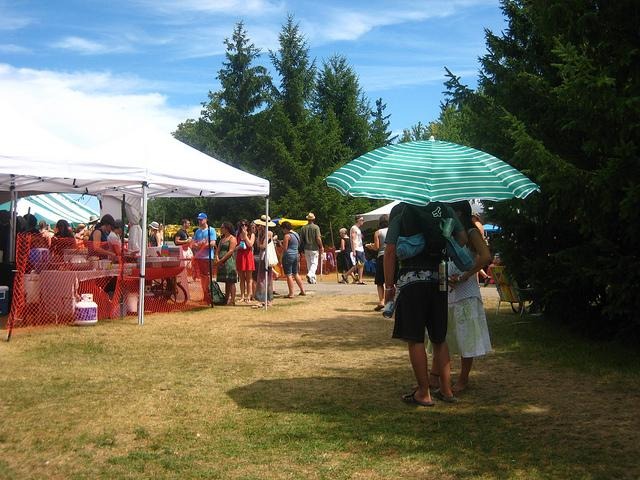What is the green umbrella being used to block?

Choices:
A) sun
B) wind
C) bugs
D) rain sun 